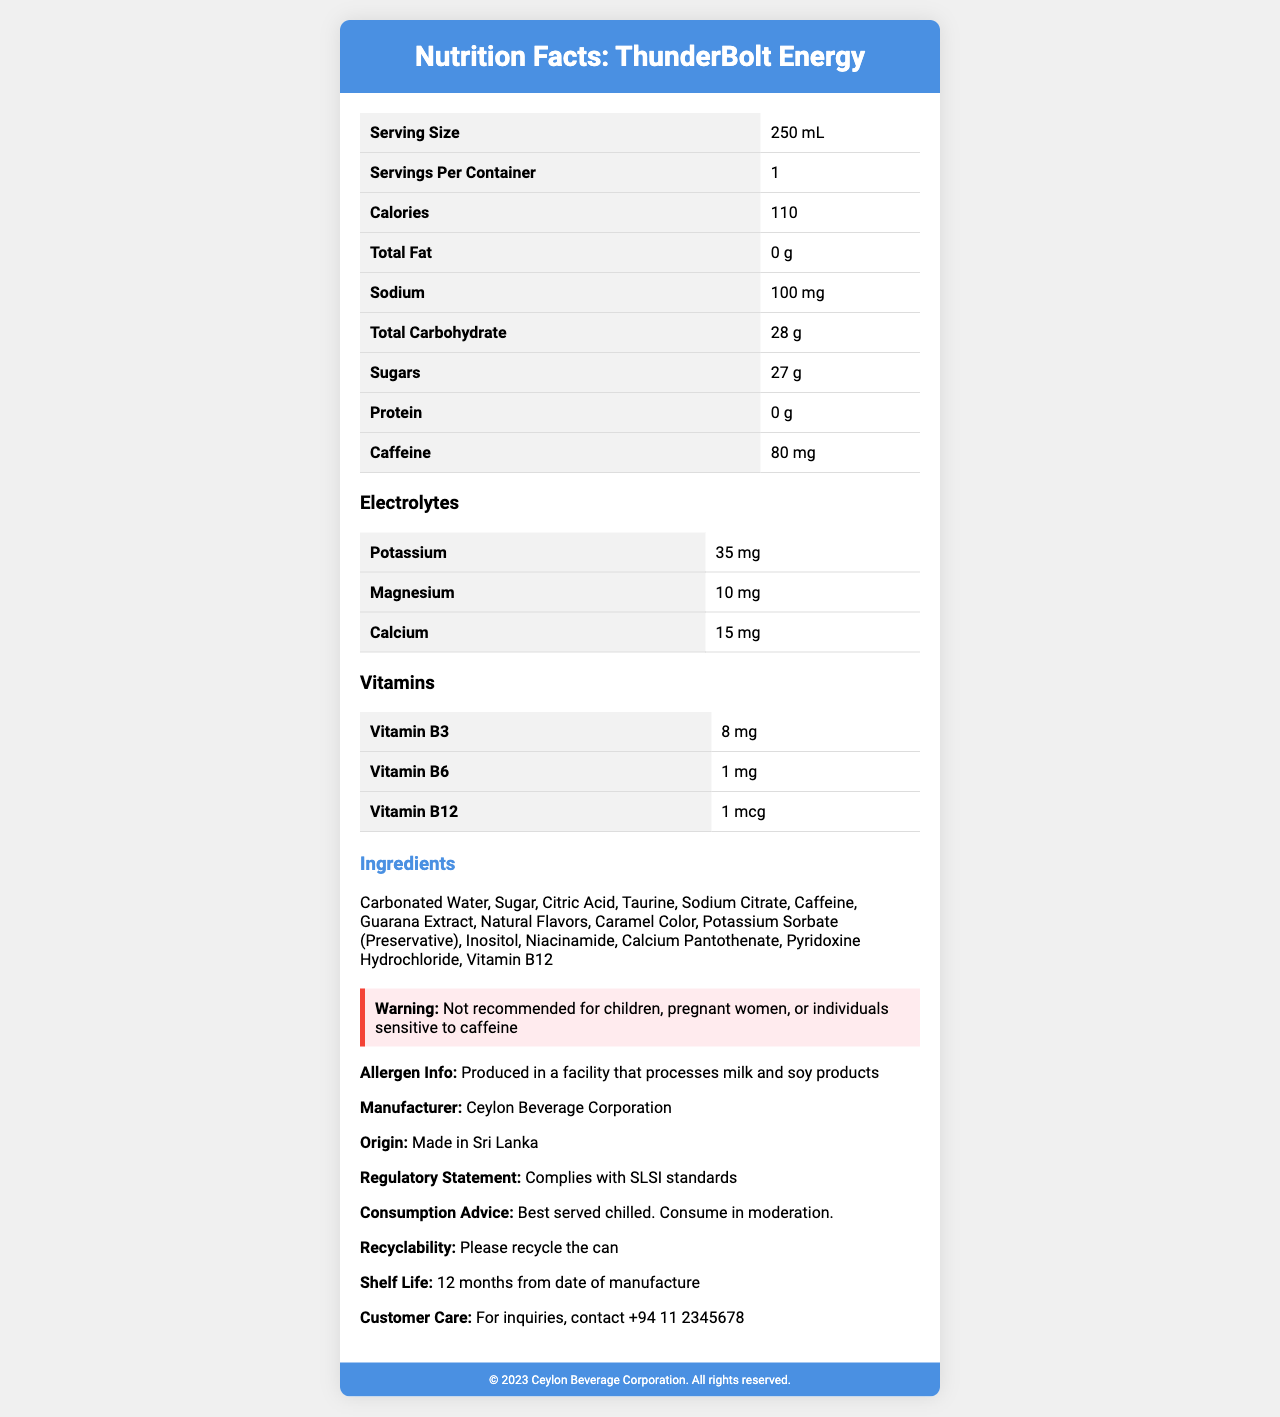What is the serving size of ThunderBolt Energy? The document states that the serving size is 250 mL.
Answer: 250 mL How much caffeine does one serving of ThunderBolt Energy contain? The document lists caffeine content as 80 mg per serving.
Answer: 80 mg Name three electrolytes present in ThunderBolt Energy. The document lists Potassium (35 mg), Magnesium (10 mg), and Calcium (15 mg) as electrolytes in the drink.
Answer: Potassium, Magnesium, Calcium Who manufactures ThunderBolt Energy? The document mentions that the manufacturer is Ceylon Beverage Corporation.
Answer: Ceylon Beverage Corporation Is this product suitable for children? The warning section explicitly states that the product is not recommended for children.
Answer: No Which vitamin is present in the highest amount in ThunderBolt Energy? A. Vitamin B3 B. Vitamin B6 C. Vitamin B12 Based on the nutrition facts, Vitamin B3 (Niacin) is present in the highest amount at 8 mg.
Answer: A. Vitamin B3 How many grams of sugars are in one serving of ThunderBolt Energy? A. 10 g B. 27 g C. 35 g The nutrition facts state that there are 27 grams of sugars per serving.
Answer: B. 27 g Does ThunderBolt Energy contain any fat? The nutrition facts indicate that the total fat content is 0 g.
Answer: No Is this product produced in Sri Lanka? The document states the origin as "Made in Sri Lanka."
Answer: Yes What is the warning provided in the document? This is stated in the warning section of the document.
Answer: Not recommended for children, pregnant women, or individuals sensitive to caffeine Summarize the main information provided by the nutrition facts label of ThunderBolt Energy. The provided explanation describes the essential components of the nutrition facts and additional details about the product as listed in the document.
Answer: ThunderBolt Energy is a Sri Lankan energy drink with a serving size of 250 mL. It contains 110 calories, 0 g fat, 100 mg sodium, 28 g carbohydrates, including 27 g sugars, and 0 g protein. It also contains 80 mg of caffeine and electrolytes like potassium (35 mg), magnesium (10 mg), and calcium (15 mg). The drink includes vitamins B3 (8 mg), B6 (1 mg), and B12 (1 mcg). The label includes ingredients, allergen info, warnings, consumption advice, regulatory compliance, and manufacturer details. Does the document mention the product's flavor? The document lists ingredients including "Natural Flavors," but it does not specify the exact flavor of the product.
Answer: Not enough information 